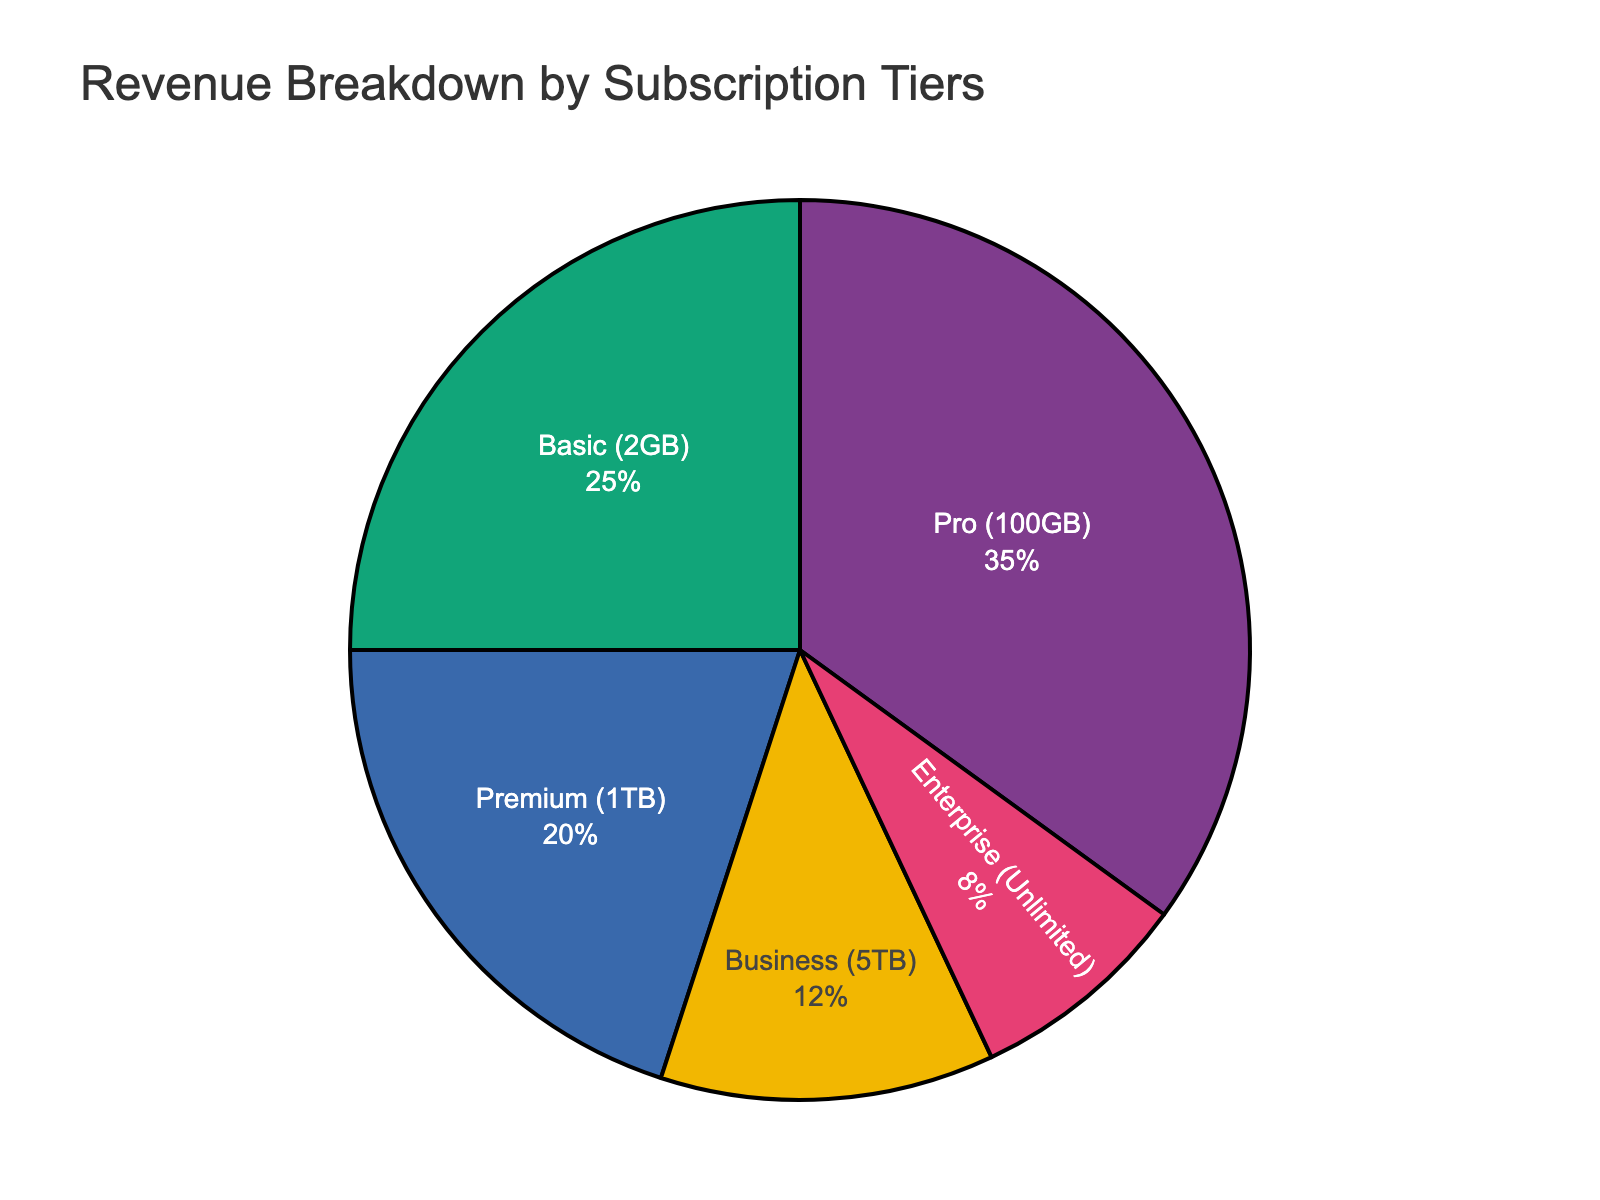What's the largest revenue percentage among the subscription tiers? The pie chart shows different subscription tiers and their associated revenue percentages. The highest revenue percentage is the largest segment.
Answer: Pro (100GB) Which tier generates the least revenue? The smallest segment in the pie chart represents the tier with the smallest revenue percentage.
Answer: Enterprise (Unlimited) How much more revenue does the Pro tier generate compared to the Business tier? The Pro tier accounts for 35% and the Business tier accounts for 12%. Subtract the smaller percentage from the larger percentage (35% - 12%).
Answer: 23% What's the total revenue percentage generated by the Premium and Business tiers together? Add the revenue percentages of the Premium tier (20%) and the Business tier (12%).
Answer: 32% If the Basic tier's revenue increased by 10%, what would its new revenue percentage be? Starting with the Basic tier's current percentage of 25%, add 10% to this number (25% + 10%).
Answer: 35% What’s the average revenue percentage of all subscription tiers? Sum all the percentages (25 + 35 + 20 + 12 + 8 = 100), then divide by the number of tiers (5).
Answer: 20% Which subscription tier is visually represented by the largest segment of the pie chart? The largest visual segment on the pie chart corresponds to the Pro (100GB) tier.
Answer: Pro (100GB) Does the combined revenue percentage of the Basic and Enterprise tiers exceed 30%? Add the Basic tier's percentage (25%) and the Enterprise tier's percentage (8%) to see if the sum exceeds 30% (25% + 8%).
Answer: No What is the percentage difference between Basic and Premium tiers? Subtract the smaller percentage (Premium’s 20%) from the larger percentage (Basic’s 25%) (25% - 20%).
Answer: 5% Arrange the tiers in descending order of revenue percentage. Visually identify the segments from largest to smallest and list their names: Pro (100GB), Basic (2GB), Premium (1TB), Business (5TB), Enterprise (Unlimited).
Answer: Pro (100GB), Basic (2GB), Premium (1TB), Business (5TB), Enterprise (Unlimited) 